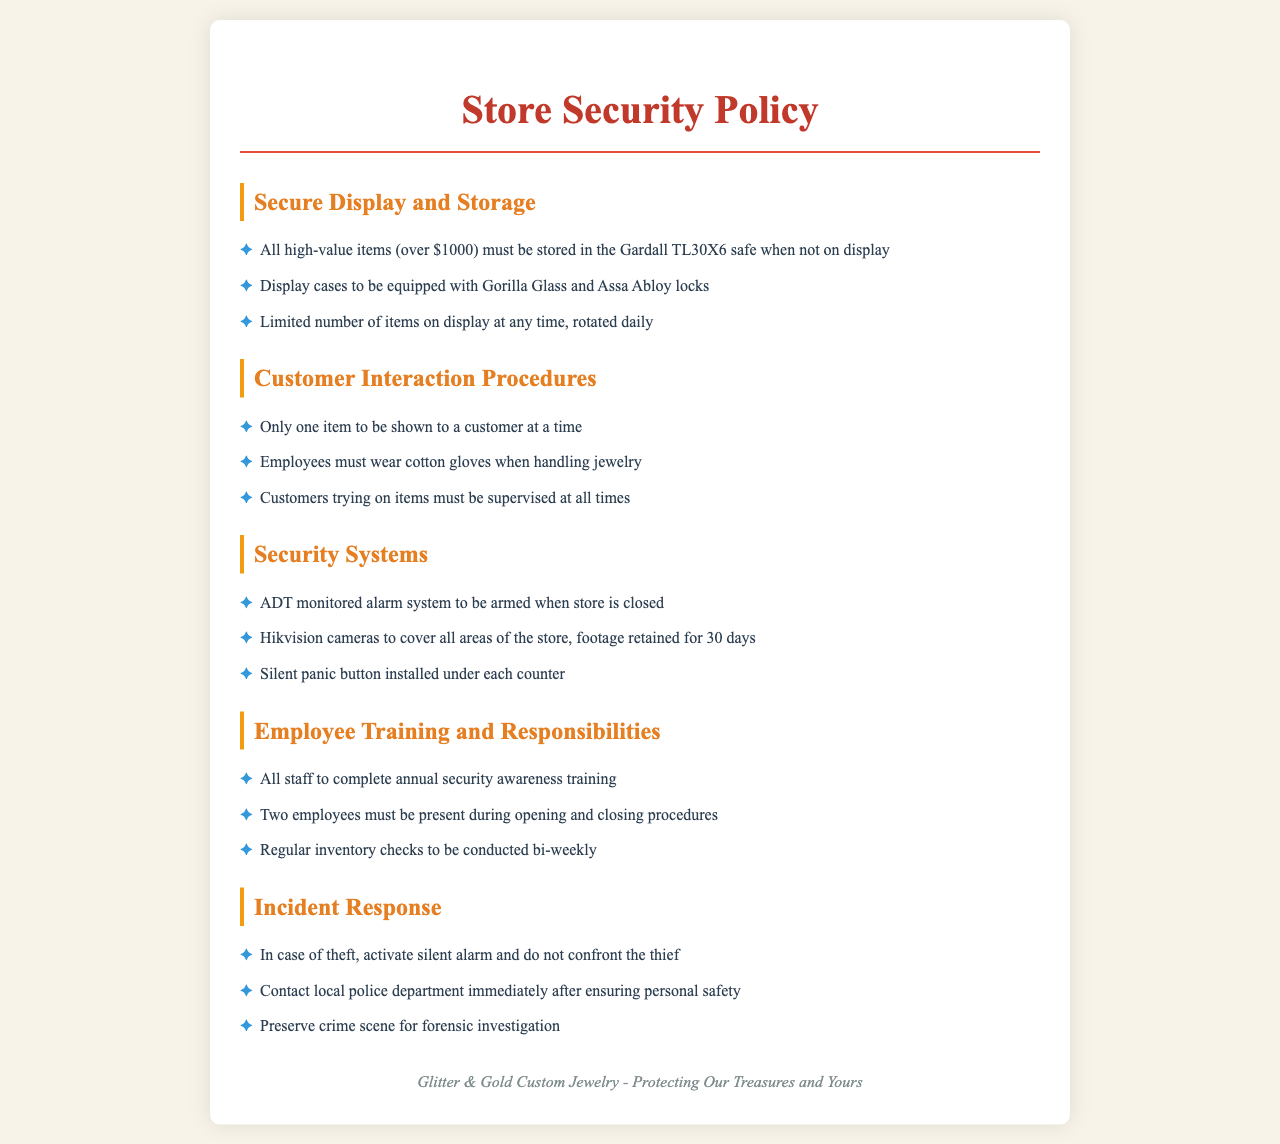What is the minimum value for items to be stored in the safe? The policy mandates that all high-value items must be stored in the safe when not on display, and this is set at over $1000.
Answer: over $1000 How many items can be shown to a customer at one time? The policy states that only one item may be shown to a customer at a time during customer interactions.
Answer: one What type of glass is required for display cases? The document specifies that display cases must be equipped with Gorilla Glass to enhance security.
Answer: Gorilla Glass How often should staff complete the security awareness training? The policy outlines that all staff must complete this training annually to ensure up-to-date knowledge on security practices.
Answer: annually What type of alarm system is used in the store? The security policy indicates that an ADT monitored alarm system is to be used when the store is closed.
Answer: ADT monitored alarm system What should be done immediately after a theft occurs? The first action specified is to contact the local police department after ensuring personal safety post-theft.
Answer: contact local police department How many employees are required during opening and closing procedures? The policy mandates that two employees must be present during these procedures to enhance security.
Answer: two What frequency are inventory checks conducted? The document states that regular inventory checks should be completed bi-weekly to account for merchandise.
Answer: bi-weekly What is installed under each counter for emergencies? A silent panic button is specified in the policies as installed under each counter for security emergencies.
Answer: silent panic button 